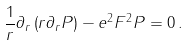Convert formula to latex. <formula><loc_0><loc_0><loc_500><loc_500>\frac { 1 } { r } \partial _ { r } \left ( r \partial _ { r } P \right ) - e ^ { 2 } F ^ { 2 } P = 0 \, .</formula> 